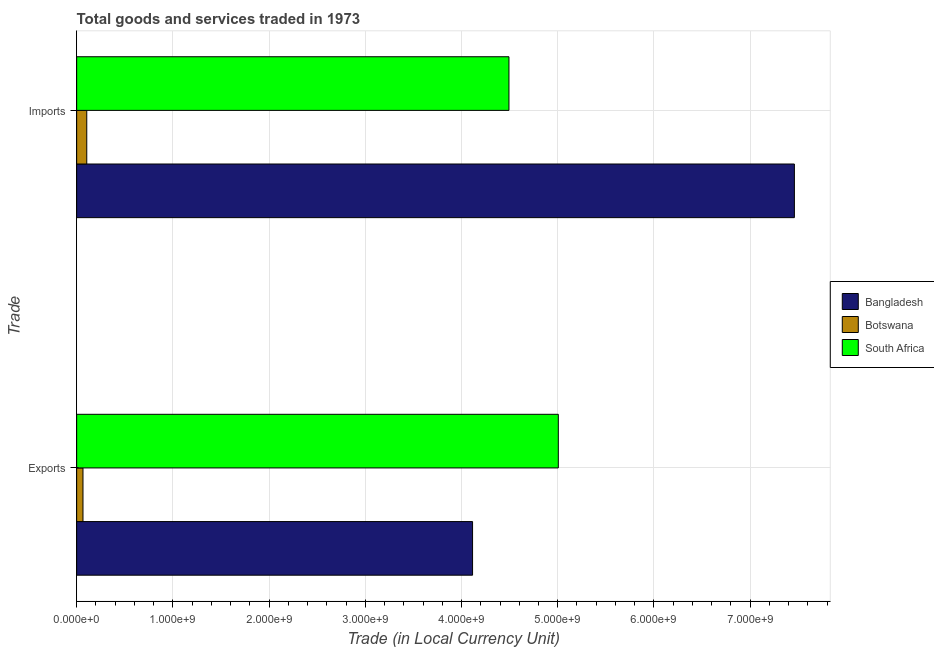How many different coloured bars are there?
Offer a terse response. 3. Are the number of bars per tick equal to the number of legend labels?
Ensure brevity in your answer.  Yes. Are the number of bars on each tick of the Y-axis equal?
Provide a succinct answer. Yes. How many bars are there on the 2nd tick from the bottom?
Give a very brief answer. 3. What is the label of the 2nd group of bars from the top?
Your answer should be compact. Exports. What is the export of goods and services in South Africa?
Offer a very short reply. 5.01e+09. Across all countries, what is the maximum export of goods and services?
Provide a succinct answer. 5.01e+09. Across all countries, what is the minimum export of goods and services?
Your answer should be compact. 6.58e+07. In which country was the export of goods and services maximum?
Offer a very short reply. South Africa. In which country was the imports of goods and services minimum?
Make the answer very short. Botswana. What is the total imports of goods and services in the graph?
Provide a succinct answer. 1.21e+1. What is the difference between the export of goods and services in Botswana and that in Bangladesh?
Provide a short and direct response. -4.05e+09. What is the difference between the imports of goods and services in South Africa and the export of goods and services in Botswana?
Keep it short and to the point. 4.43e+09. What is the average imports of goods and services per country?
Offer a terse response. 4.02e+09. What is the difference between the export of goods and services and imports of goods and services in Bangladesh?
Offer a very short reply. -3.34e+09. In how many countries, is the imports of goods and services greater than 3600000000 LCU?
Provide a succinct answer. 2. What is the ratio of the export of goods and services in Bangladesh to that in South Africa?
Your answer should be very brief. 0.82. In how many countries, is the imports of goods and services greater than the average imports of goods and services taken over all countries?
Make the answer very short. 2. What does the 1st bar from the top in Exports represents?
Ensure brevity in your answer.  South Africa. How many bars are there?
Ensure brevity in your answer.  6. How many countries are there in the graph?
Make the answer very short. 3. What is the difference between two consecutive major ticks on the X-axis?
Ensure brevity in your answer.  1.00e+09. Are the values on the major ticks of X-axis written in scientific E-notation?
Offer a very short reply. Yes. Where does the legend appear in the graph?
Your answer should be compact. Center right. How many legend labels are there?
Ensure brevity in your answer.  3. How are the legend labels stacked?
Offer a terse response. Vertical. What is the title of the graph?
Provide a short and direct response. Total goods and services traded in 1973. Does "Luxembourg" appear as one of the legend labels in the graph?
Provide a short and direct response. No. What is the label or title of the X-axis?
Give a very brief answer. Trade (in Local Currency Unit). What is the label or title of the Y-axis?
Your answer should be very brief. Trade. What is the Trade (in Local Currency Unit) of Bangladesh in Exports?
Make the answer very short. 4.11e+09. What is the Trade (in Local Currency Unit) in Botswana in Exports?
Your response must be concise. 6.58e+07. What is the Trade (in Local Currency Unit) in South Africa in Exports?
Make the answer very short. 5.01e+09. What is the Trade (in Local Currency Unit) of Bangladesh in Imports?
Your answer should be very brief. 7.46e+09. What is the Trade (in Local Currency Unit) in Botswana in Imports?
Offer a terse response. 1.05e+08. What is the Trade (in Local Currency Unit) in South Africa in Imports?
Give a very brief answer. 4.49e+09. Across all Trade, what is the maximum Trade (in Local Currency Unit) in Bangladesh?
Ensure brevity in your answer.  7.46e+09. Across all Trade, what is the maximum Trade (in Local Currency Unit) of Botswana?
Your answer should be compact. 1.05e+08. Across all Trade, what is the maximum Trade (in Local Currency Unit) of South Africa?
Your answer should be compact. 5.01e+09. Across all Trade, what is the minimum Trade (in Local Currency Unit) in Bangladesh?
Your response must be concise. 4.11e+09. Across all Trade, what is the minimum Trade (in Local Currency Unit) of Botswana?
Make the answer very short. 6.58e+07. Across all Trade, what is the minimum Trade (in Local Currency Unit) in South Africa?
Make the answer very short. 4.49e+09. What is the total Trade (in Local Currency Unit) in Bangladesh in the graph?
Provide a short and direct response. 1.16e+1. What is the total Trade (in Local Currency Unit) of Botswana in the graph?
Offer a very short reply. 1.71e+08. What is the total Trade (in Local Currency Unit) in South Africa in the graph?
Your response must be concise. 9.50e+09. What is the difference between the Trade (in Local Currency Unit) of Bangladesh in Exports and that in Imports?
Ensure brevity in your answer.  -3.34e+09. What is the difference between the Trade (in Local Currency Unit) of Botswana in Exports and that in Imports?
Make the answer very short. -3.92e+07. What is the difference between the Trade (in Local Currency Unit) in South Africa in Exports and that in Imports?
Make the answer very short. 5.13e+08. What is the difference between the Trade (in Local Currency Unit) of Bangladesh in Exports and the Trade (in Local Currency Unit) of Botswana in Imports?
Keep it short and to the point. 4.01e+09. What is the difference between the Trade (in Local Currency Unit) of Bangladesh in Exports and the Trade (in Local Currency Unit) of South Africa in Imports?
Your response must be concise. -3.78e+08. What is the difference between the Trade (in Local Currency Unit) of Botswana in Exports and the Trade (in Local Currency Unit) of South Africa in Imports?
Keep it short and to the point. -4.43e+09. What is the average Trade (in Local Currency Unit) of Bangladesh per Trade?
Provide a short and direct response. 5.79e+09. What is the average Trade (in Local Currency Unit) of Botswana per Trade?
Provide a succinct answer. 8.54e+07. What is the average Trade (in Local Currency Unit) of South Africa per Trade?
Your response must be concise. 4.75e+09. What is the difference between the Trade (in Local Currency Unit) of Bangladesh and Trade (in Local Currency Unit) of Botswana in Exports?
Give a very brief answer. 4.05e+09. What is the difference between the Trade (in Local Currency Unit) of Bangladesh and Trade (in Local Currency Unit) of South Africa in Exports?
Give a very brief answer. -8.91e+08. What is the difference between the Trade (in Local Currency Unit) of Botswana and Trade (in Local Currency Unit) of South Africa in Exports?
Your answer should be compact. -4.94e+09. What is the difference between the Trade (in Local Currency Unit) of Bangladesh and Trade (in Local Currency Unit) of Botswana in Imports?
Your answer should be compact. 7.35e+09. What is the difference between the Trade (in Local Currency Unit) in Bangladesh and Trade (in Local Currency Unit) in South Africa in Imports?
Give a very brief answer. 2.97e+09. What is the difference between the Trade (in Local Currency Unit) of Botswana and Trade (in Local Currency Unit) of South Africa in Imports?
Keep it short and to the point. -4.39e+09. What is the ratio of the Trade (in Local Currency Unit) in Bangladesh in Exports to that in Imports?
Your answer should be very brief. 0.55. What is the ratio of the Trade (in Local Currency Unit) in Botswana in Exports to that in Imports?
Provide a succinct answer. 0.63. What is the ratio of the Trade (in Local Currency Unit) in South Africa in Exports to that in Imports?
Provide a short and direct response. 1.11. What is the difference between the highest and the second highest Trade (in Local Currency Unit) of Bangladesh?
Make the answer very short. 3.34e+09. What is the difference between the highest and the second highest Trade (in Local Currency Unit) in Botswana?
Give a very brief answer. 3.92e+07. What is the difference between the highest and the second highest Trade (in Local Currency Unit) in South Africa?
Provide a succinct answer. 5.13e+08. What is the difference between the highest and the lowest Trade (in Local Currency Unit) of Bangladesh?
Your response must be concise. 3.34e+09. What is the difference between the highest and the lowest Trade (in Local Currency Unit) in Botswana?
Provide a succinct answer. 3.92e+07. What is the difference between the highest and the lowest Trade (in Local Currency Unit) of South Africa?
Keep it short and to the point. 5.13e+08. 